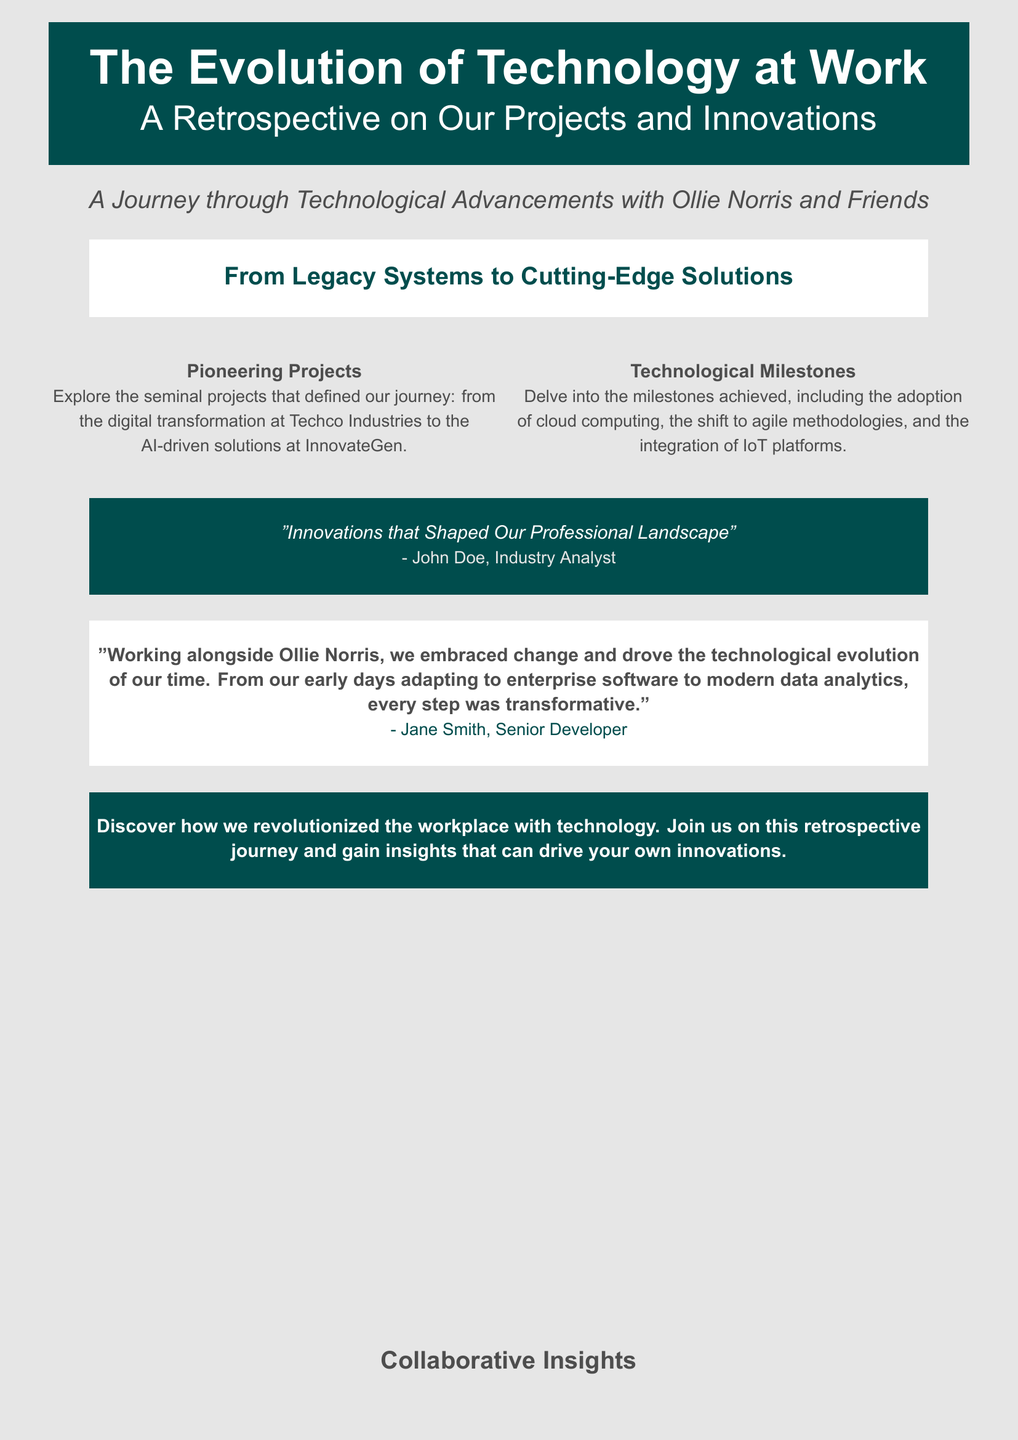What is the title of the book? The title is prominently displayed in the document's header and is "The Evolution of Technology at Work."
Answer: The Evolution of Technology at Work What is the subtitle of the book? The subtitle is placed beneath the main title and reads "A Retrospective on Our Projects and Innovations."
Answer: A Retrospective on Our Projects and Innovations Who is the primary individual associated with the book? The book mentions Ollie Norris as a key figure in the journey of technology at work.
Answer: Ollie Norris What color is the background of the book cover? The document specifies that the background color is light gray.
Answer: Light gray Which company is highlighted for its digital transformation project? The document refers to Techco Industries for their digital transformation project.
Answer: Techco Industries What type of innovations does the book discuss? The book covers innovations ranging from legacy systems to cutting-edge solutions in technology.
Answer: Cutting-edge solutions Who provided a quote regarding innovations? John Doe is identified as an industry analyst who provided a quote in the document.
Answer: John Doe What does the quote from Jane Smith emphasize? Jane Smith emphasizes the transformative nature of their journey in adapting to new technologies.
Answer: Transformative What is the main theme of the book? The theme revolves around the revolution of the workplace through technology and past innovations.
Answer: Revolution of the workplace through technology 